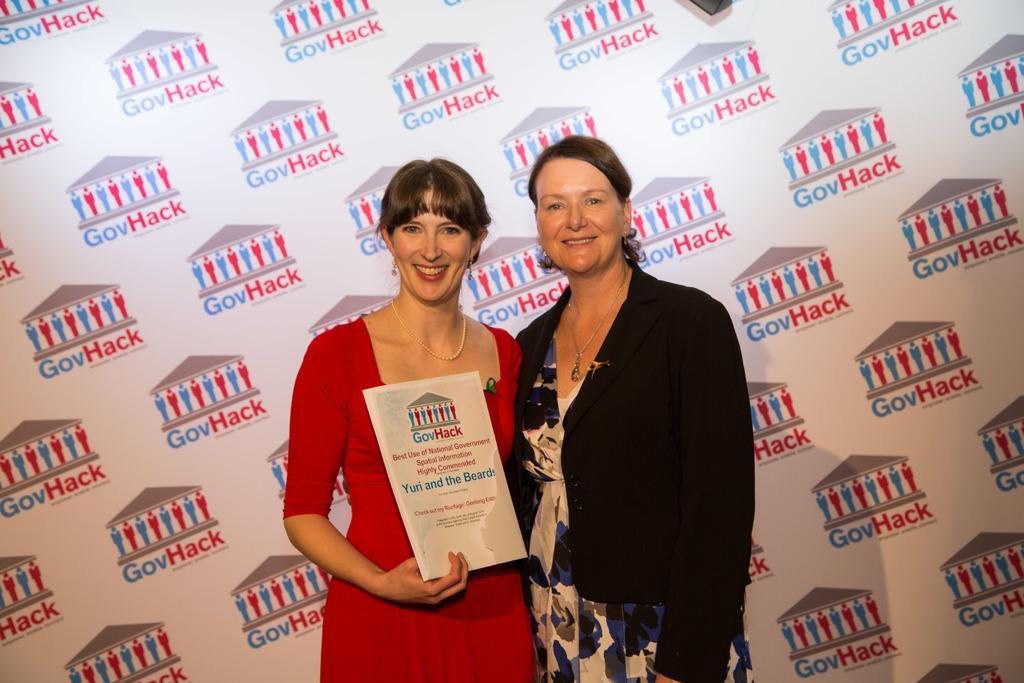How would you summarize this image in a sentence or two? There are two women standing as we can in the middle of this image. The woman standing on the left side is holding a book. We can see a board in the background. 